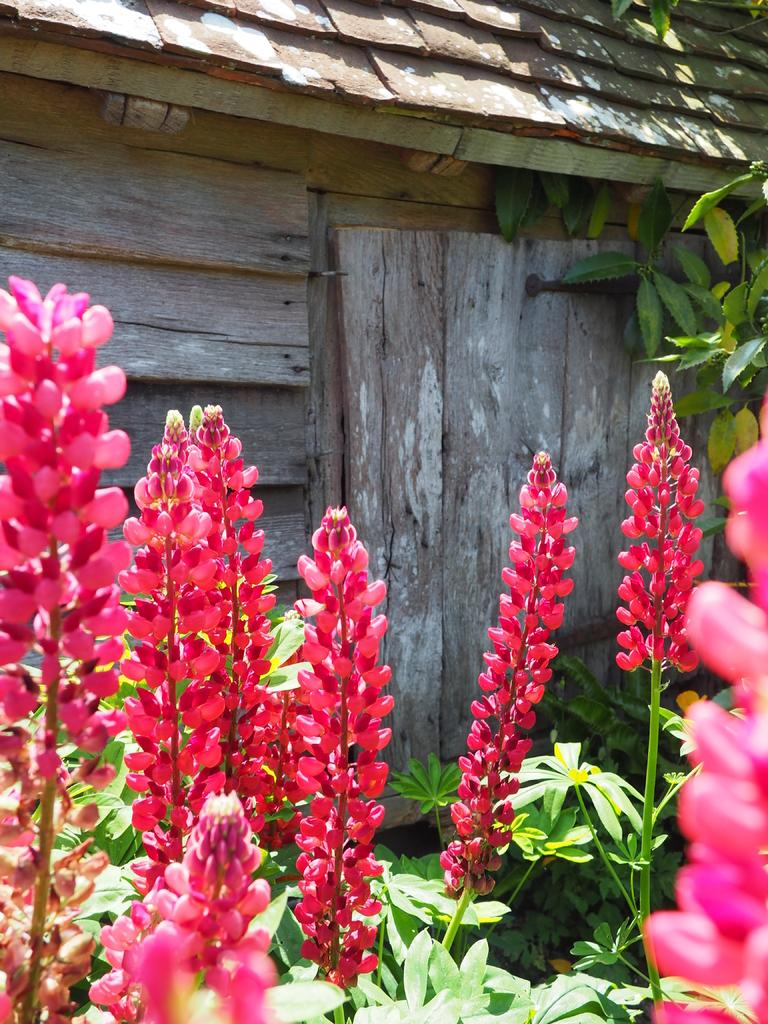What type of living organisms can be seen in the image? Flowers and plants are visible in the image. Can you describe the material of the planks in the image? The wooden planks in the background of the image are made of wood. What type of fairies can be seen interacting with the flowers in the image? There are no fairies present in the image; it only features flowers and plants. What type of fruit is growing on the plants in the image? The provided facts do not mention any fruit growing on the plants in the image, so we cannot determine the type of fruit. 